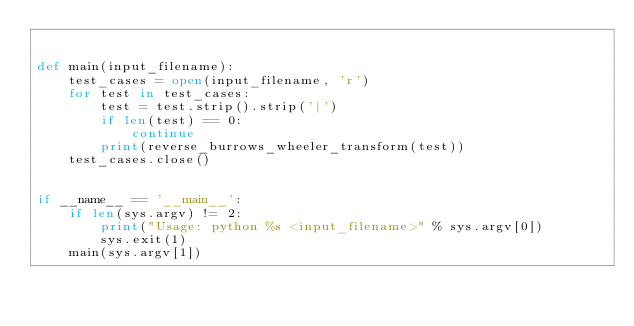<code> <loc_0><loc_0><loc_500><loc_500><_Python_>

def main(input_filename):
    test_cases = open(input_filename, 'r')
    for test in test_cases:
        test = test.strip().strip('|')
        if len(test) == 0:
            continue
        print(reverse_burrows_wheeler_transform(test))
    test_cases.close()


if __name__ == '__main__':
    if len(sys.argv) != 2:
        print("Usage: python %s <input_filename>" % sys.argv[0])
        sys.exit(1)
    main(sys.argv[1])
</code> 